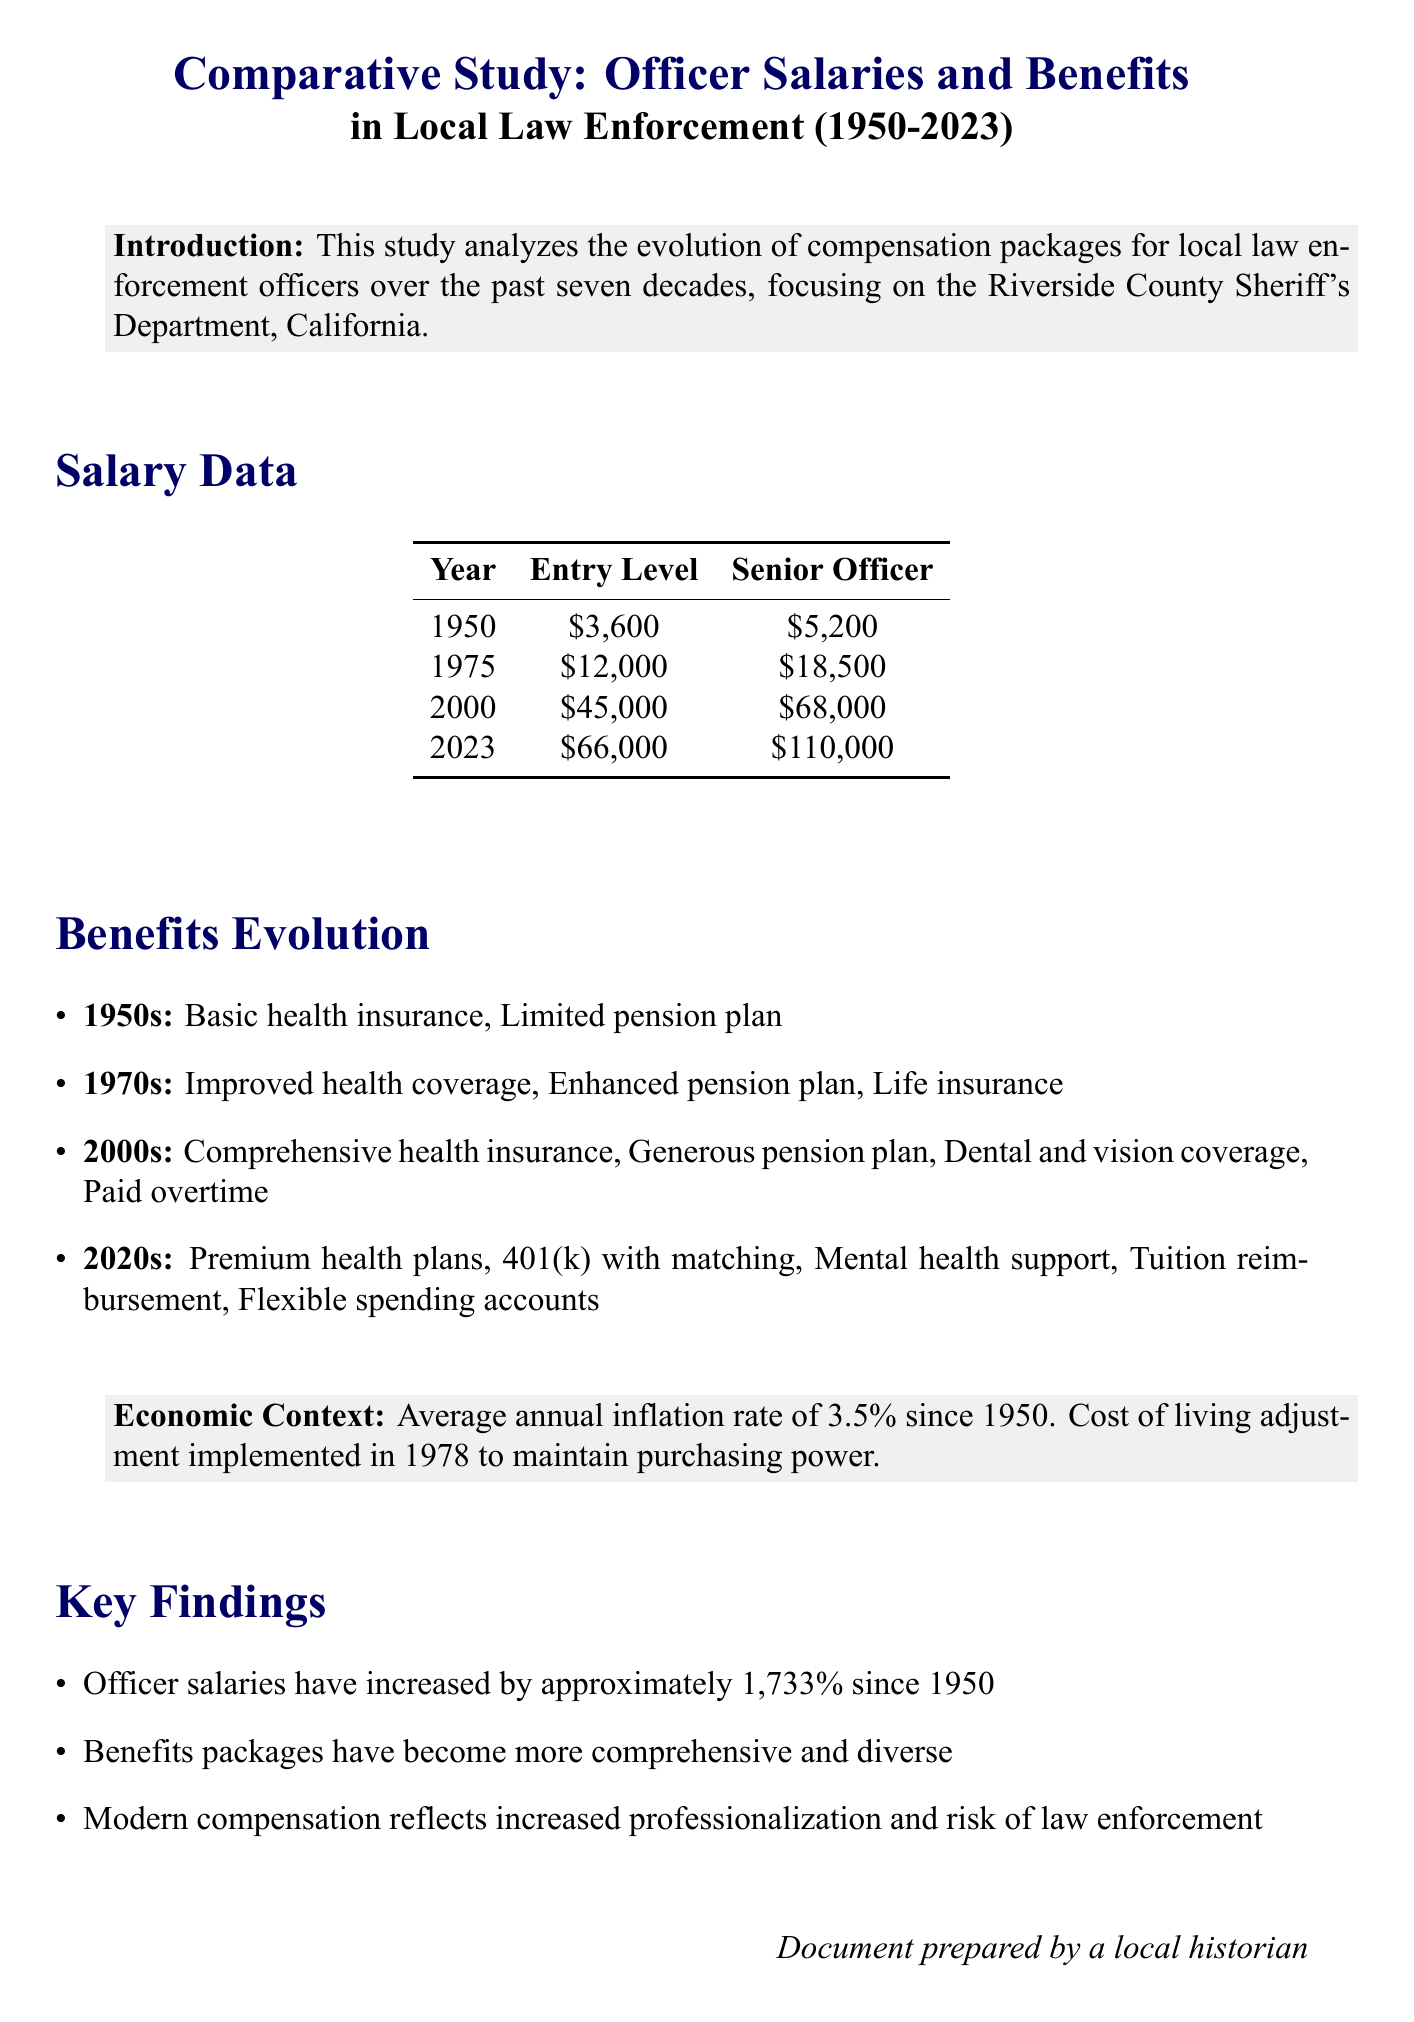What was the entry level salary in 1950? The entry level salary in 1950 is found in the salary data section, specifically listed for that year.
Answer: $3,600 What year experienced the greatest salary increase for senior officers? By comparing the senior officer salaries in the salary data, one can determine which year had the highest increase from the previous amount.
Answer: 2023 What key benefit was added in the 1970s? The benefits evolution section lists improvements by era, highlighting the new benefits introduced in the 1970s.
Answer: Life insurance What was the average annual inflation rate since 1950? This information is contained in the economic context section, which provides details about inflation affecting officer salaries.
Answer: 3.5% How much did officer salaries increase since 1950? The key findings section summarizes the percentage increase in officer salaries over the specified time frame.
Answer: 1,733% What type of retirement savings plan is mentioned for the 2020s? The benefits evolution discusses what new types of retirement savings plans have been introduced in the 2020s.
Answer: 401(k) with matching What year marks the beginning of the study? The introduction states that the analysis covers officer salaries starting from a specific year.
Answer: 1950 What type of document is this? The title and context indicate that this is a financial report focusing on a comparative analysis.
Answer: Comparative study 